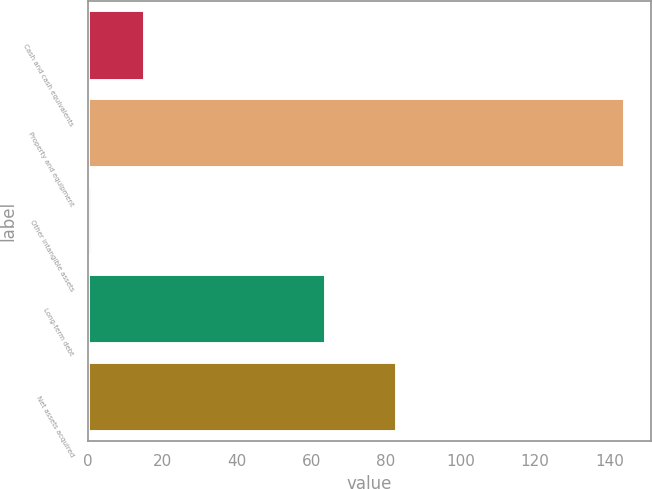<chart> <loc_0><loc_0><loc_500><loc_500><bar_chart><fcel>Cash and cash equivalents<fcel>Property and equipment<fcel>Other intangible assets<fcel>Long-term debt<fcel>Net assets acquired<nl><fcel>15.3<fcel>144<fcel>1<fcel>64<fcel>83<nl></chart> 